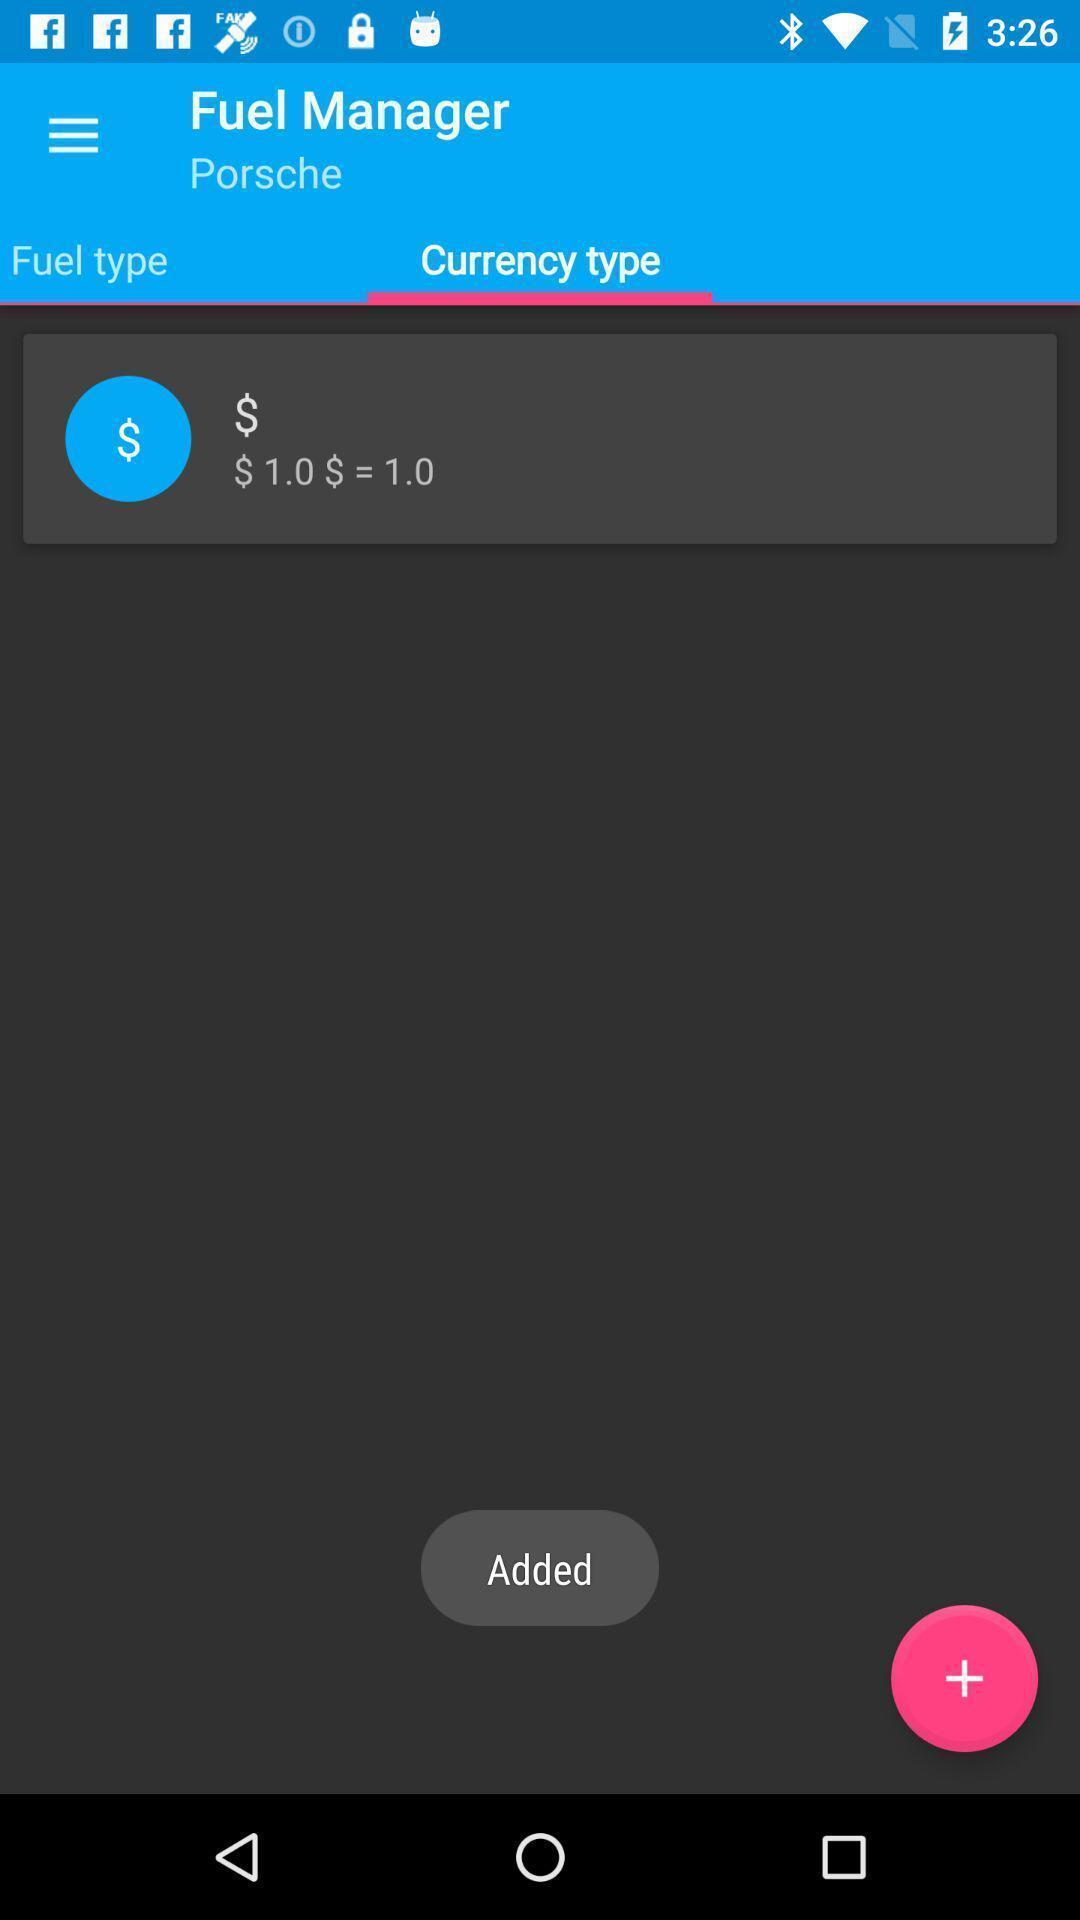Give me a summary of this screen capture. Page showing fuel consumption calculation. 